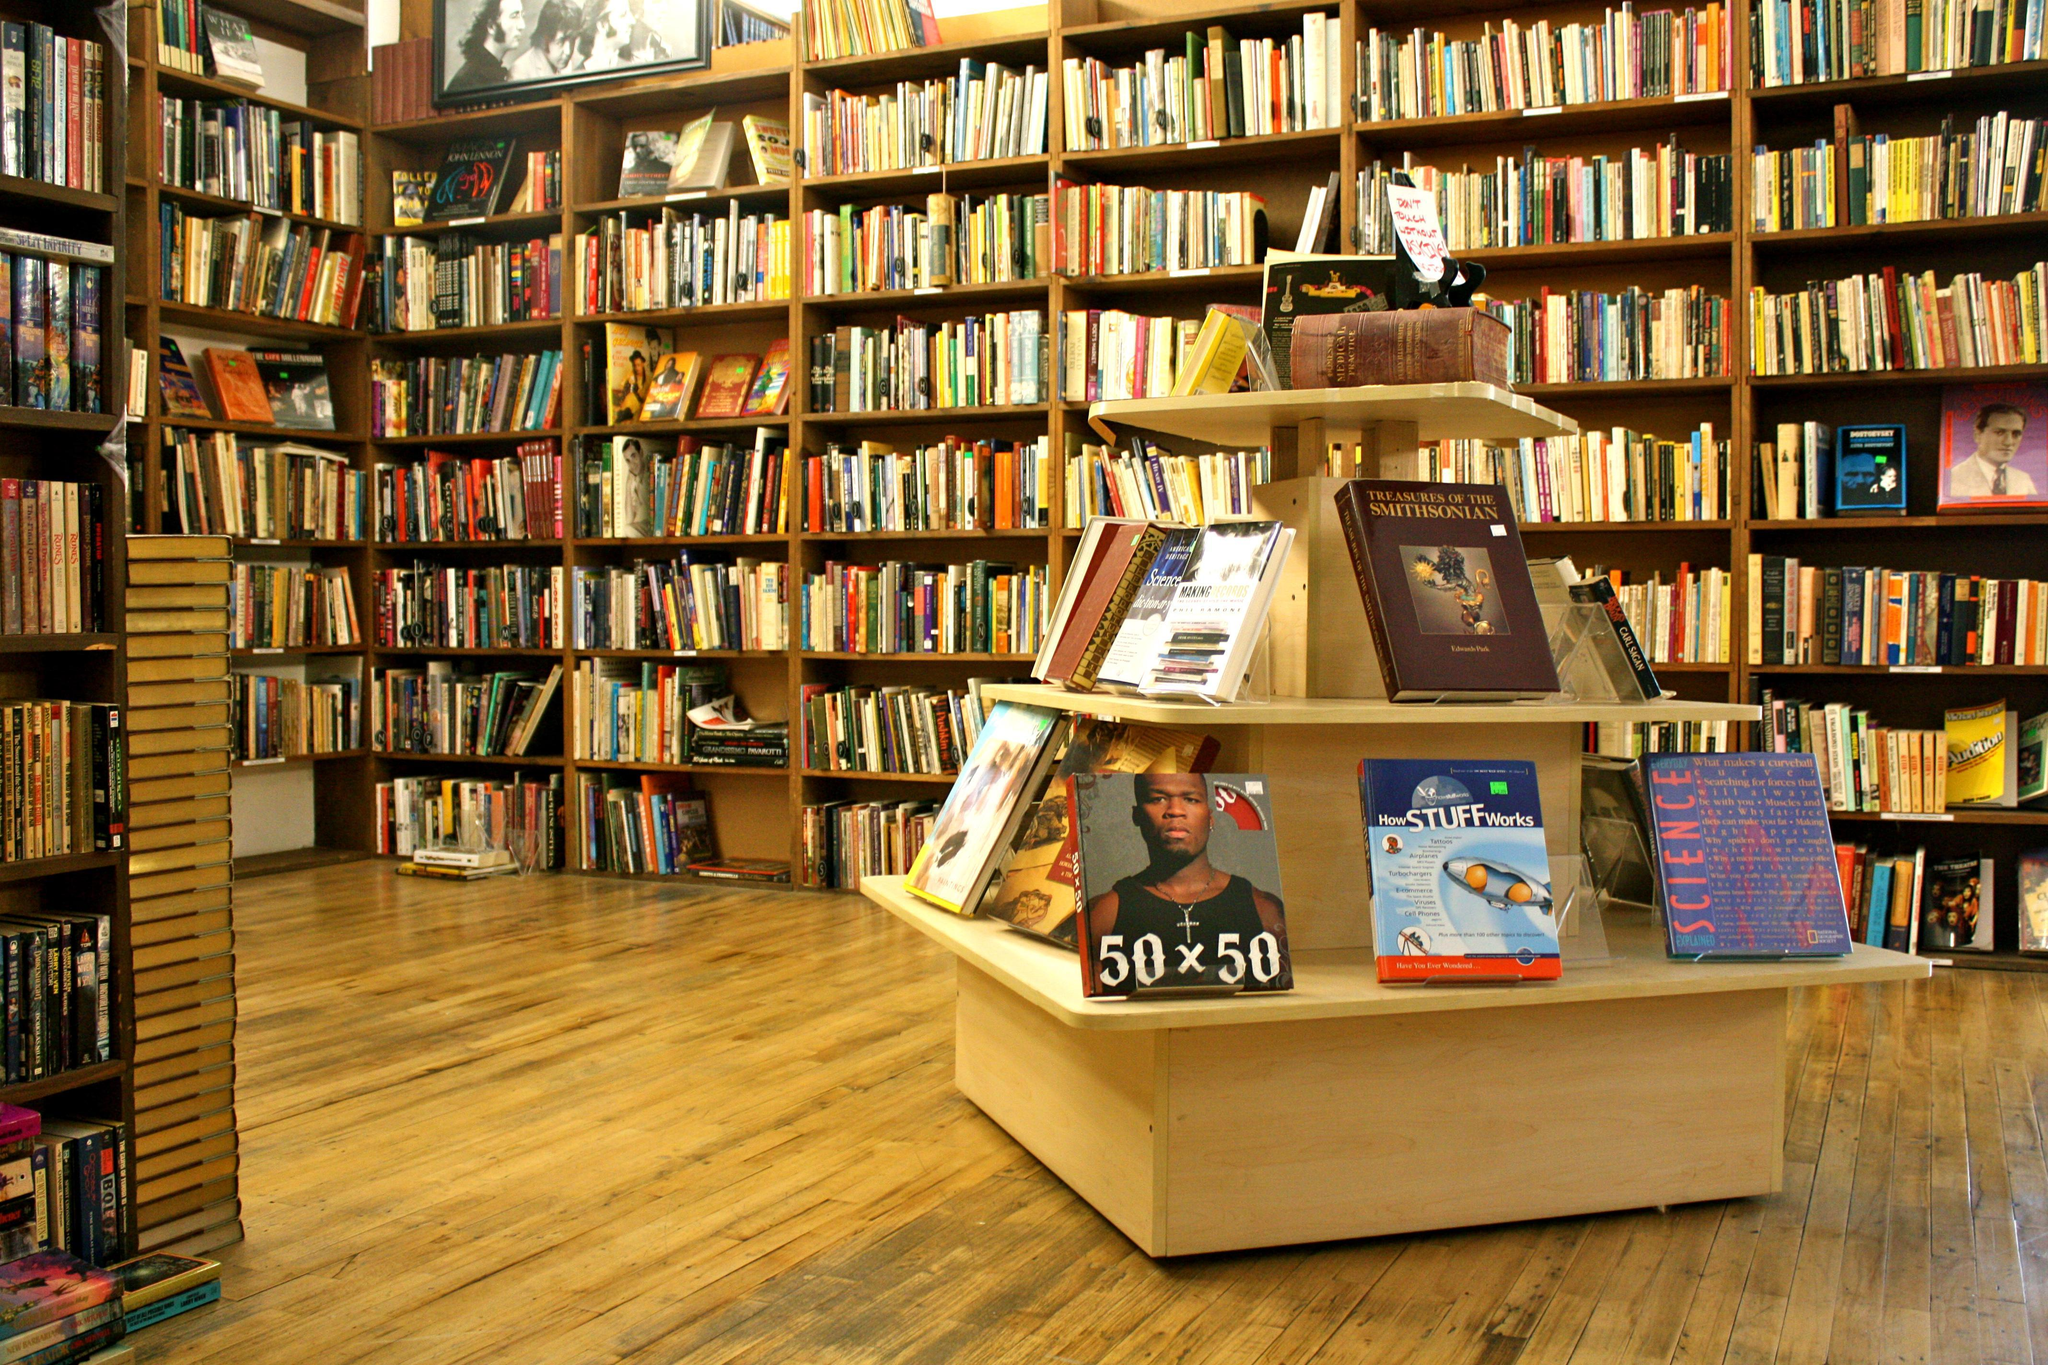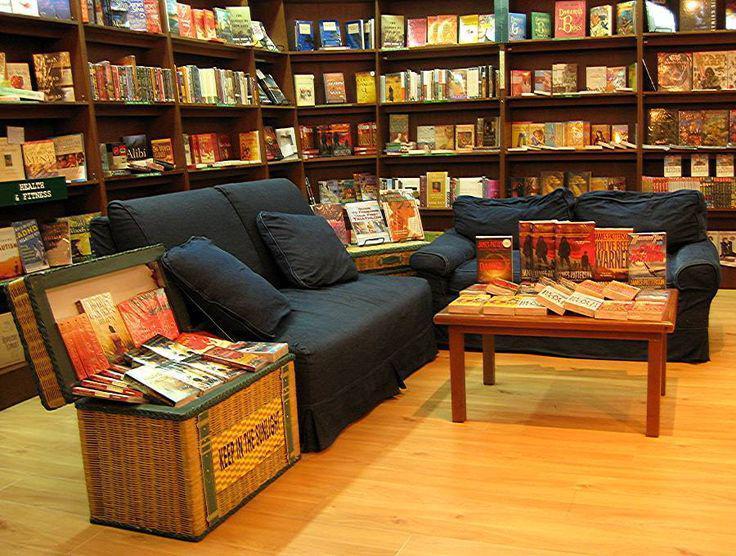The first image is the image on the left, the second image is the image on the right. For the images shown, is this caption "The left image features books arranged on tiered shelves of a wooden pyramid-shaped structure in a library with a wood floor." true? Answer yes or no. Yes. The first image is the image on the left, the second image is the image on the right. For the images displayed, is the sentence "Netting is draped above a reading area in the image on the left." factually correct? Answer yes or no. No. 